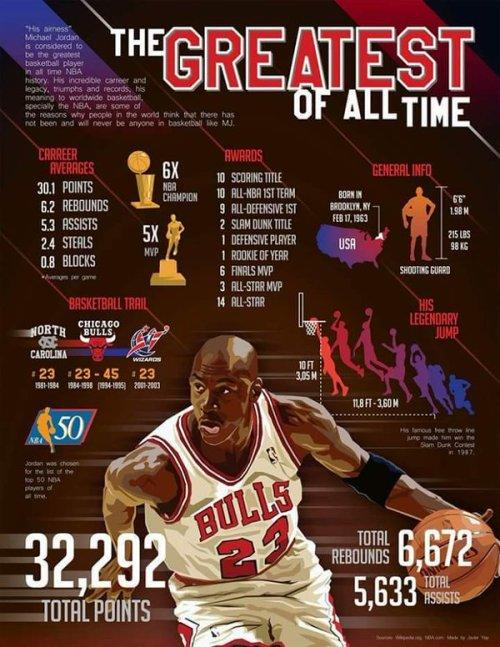Indicate a few pertinent items in this graphic. The basketball hoop is 10 feet from the ground. Michael Jordan, while playing for the North Carolina team, wore jersey number 23. According to the given information, Michael Jordan's overall score was 32,292. Michael Jordan, a renowned basketball player, wore jersey number 45 during his tenure with the Chicago Bulls. Michael Jordan weighed 215 pounds. 